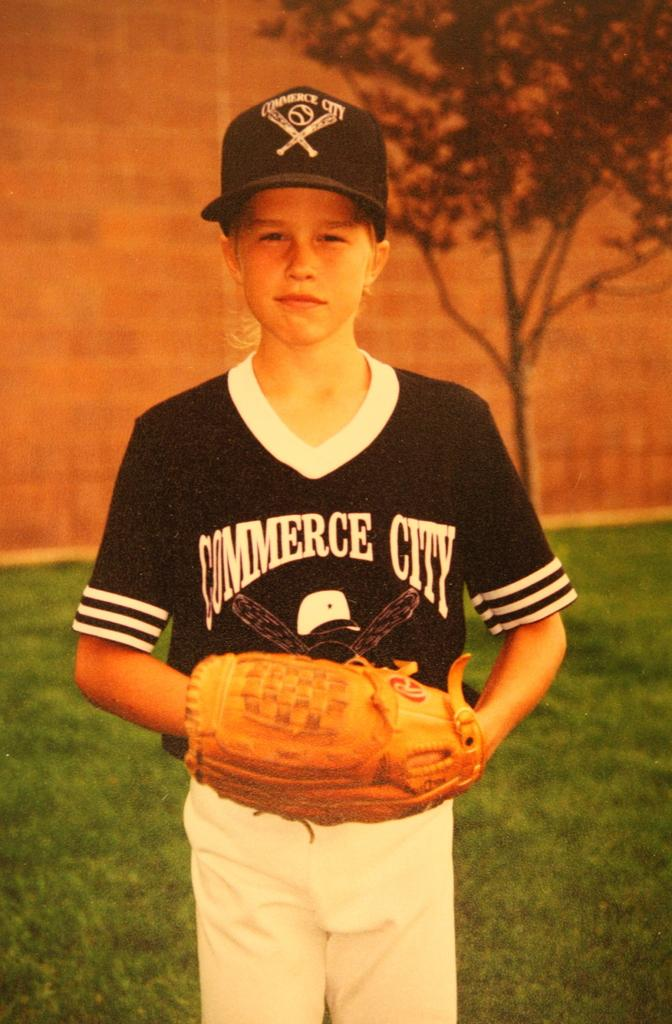<image>
Describe the image concisely. A young boy in a blue cap and a jersey that says Commerce City on it. 